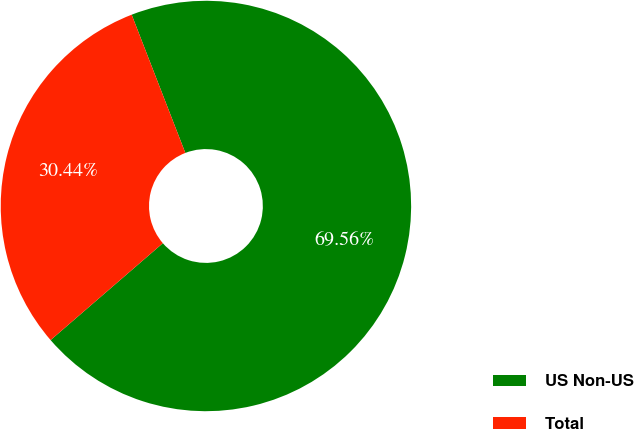<chart> <loc_0><loc_0><loc_500><loc_500><pie_chart><fcel>US Non-US<fcel>Total<nl><fcel>69.56%<fcel>30.44%<nl></chart> 